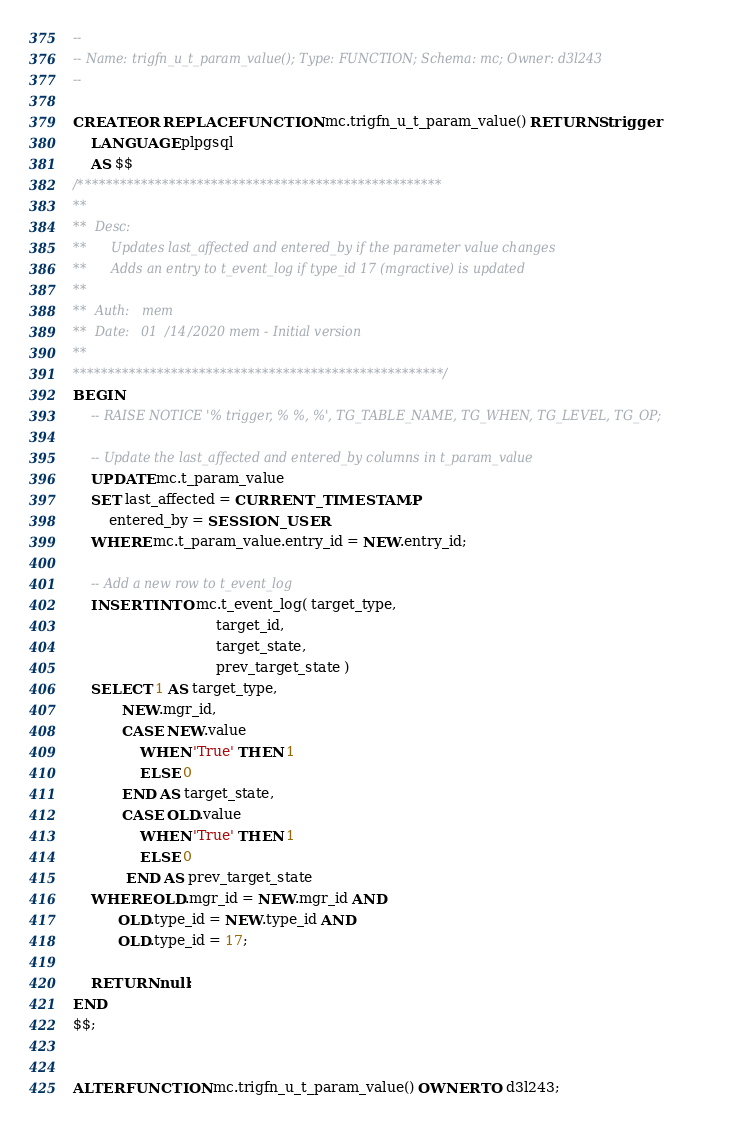Convert code to text. <code><loc_0><loc_0><loc_500><loc_500><_SQL_>--
-- Name: trigfn_u_t_param_value(); Type: FUNCTION; Schema: mc; Owner: d3l243
--

CREATE OR REPLACE FUNCTION mc.trigfn_u_t_param_value() RETURNS trigger
    LANGUAGE plpgsql
    AS $$
/****************************************************
**
**  Desc:
**      Updates last_affected and entered_by if the parameter value changes
**      Adds an entry to t_event_log if type_id 17 (mgractive) is updated
**
**  Auth:   mem
**  Date:   01/14/2020 mem - Initial version
**
*****************************************************/
BEGIN
    -- RAISE NOTICE '% trigger, % %, %', TG_TABLE_NAME, TG_WHEN, TG_LEVEL, TG_OP;

    -- Update the last_affected and entered_by columns in t_param_value
    UPDATE mc.t_param_value
    SET last_affected = CURRENT_TIMESTAMP,
        entered_by = SESSION_USER
    WHERE mc.t_param_value.entry_id = NEW.entry_id;

    -- Add a new row to t_event_log
    INSERT INTO mc.t_event_log( target_type,
                                target_id,
                                target_state,
                                prev_target_state )
    SELECT 1 AS target_type,
           NEW.mgr_id,
           CASE NEW.value
               WHEN 'True' THEN 1
               ELSE 0
           END AS target_state,
           CASE OLD.value
               WHEN 'True' THEN 1
               ELSE 0
            END AS prev_target_state
    WHERE OLD.mgr_id = NEW.mgr_id AND
          OLD.type_id = NEW.type_id AND
          OLD.type_id = 17;

    RETURN null;
END
$$;


ALTER FUNCTION mc.trigfn_u_t_param_value() OWNER TO d3l243;

</code> 